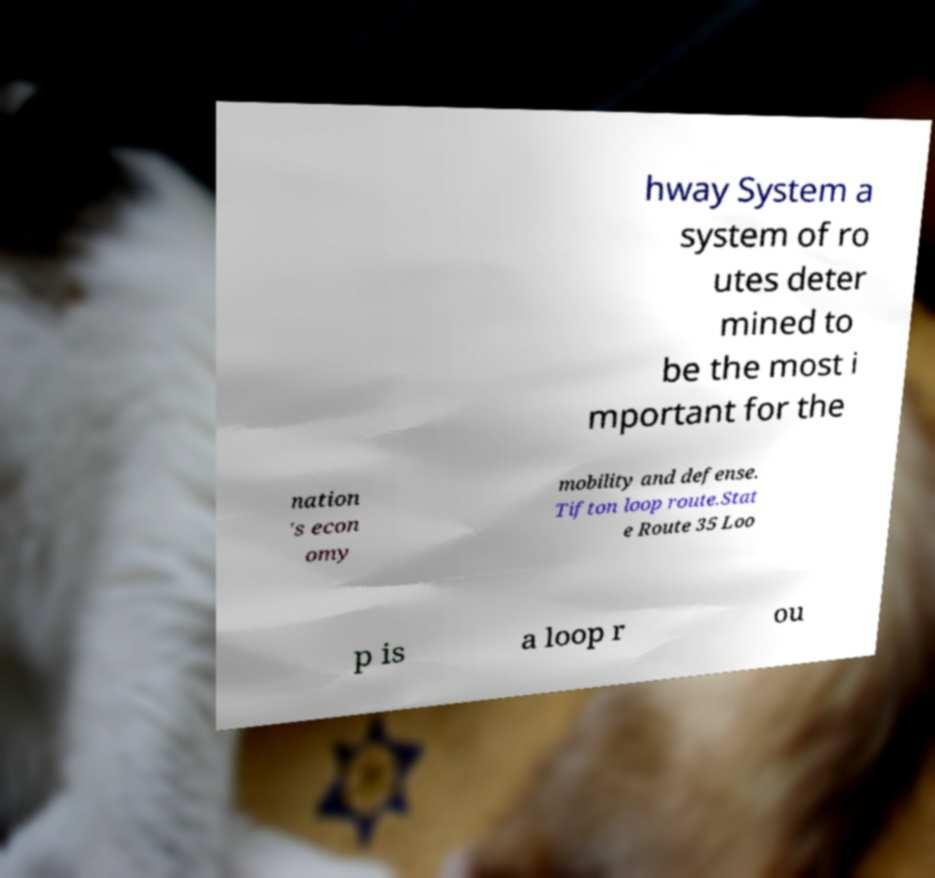Can you accurately transcribe the text from the provided image for me? hway System a system of ro utes deter mined to be the most i mportant for the nation 's econ omy mobility and defense. Tifton loop route.Stat e Route 35 Loo p is a loop r ou 